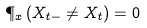<formula> <loc_0><loc_0><loc_500><loc_500>\P _ { x } \left ( X _ { t - } \not = X _ { t } \right ) = 0</formula> 